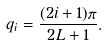<formula> <loc_0><loc_0><loc_500><loc_500>q _ { i } = \frac { ( 2 i + 1 ) \pi } { 2 L + 1 } .</formula> 